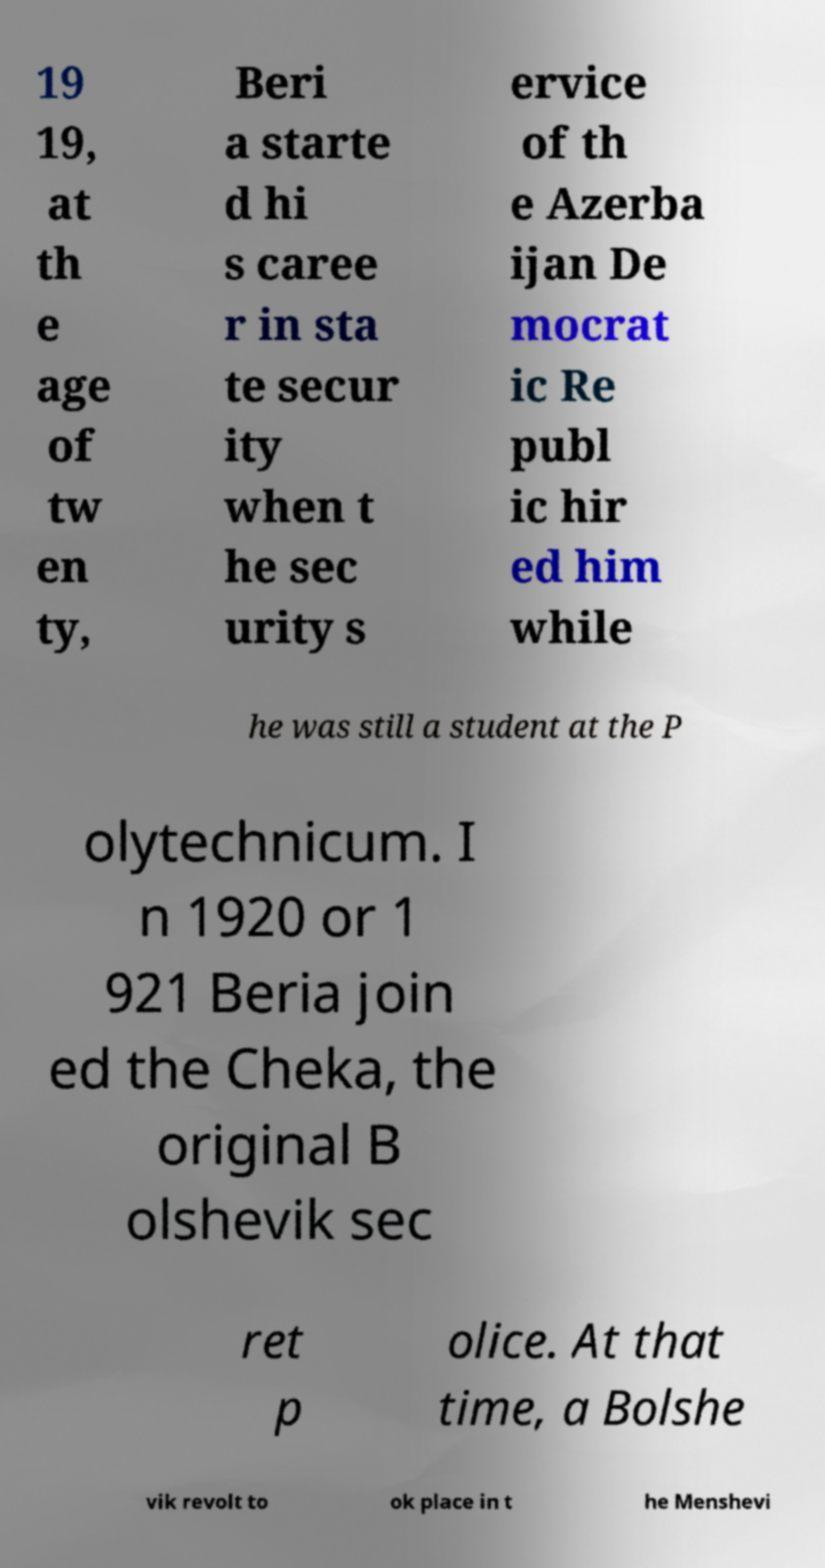There's text embedded in this image that I need extracted. Can you transcribe it verbatim? 19 19, at th e age of tw en ty, Beri a starte d hi s caree r in sta te secur ity when t he sec urity s ervice of th e Azerba ijan De mocrat ic Re publ ic hir ed him while he was still a student at the P olytechnicum. I n 1920 or 1 921 Beria join ed the Cheka, the original B olshevik sec ret p olice. At that time, a Bolshe vik revolt to ok place in t he Menshevi 